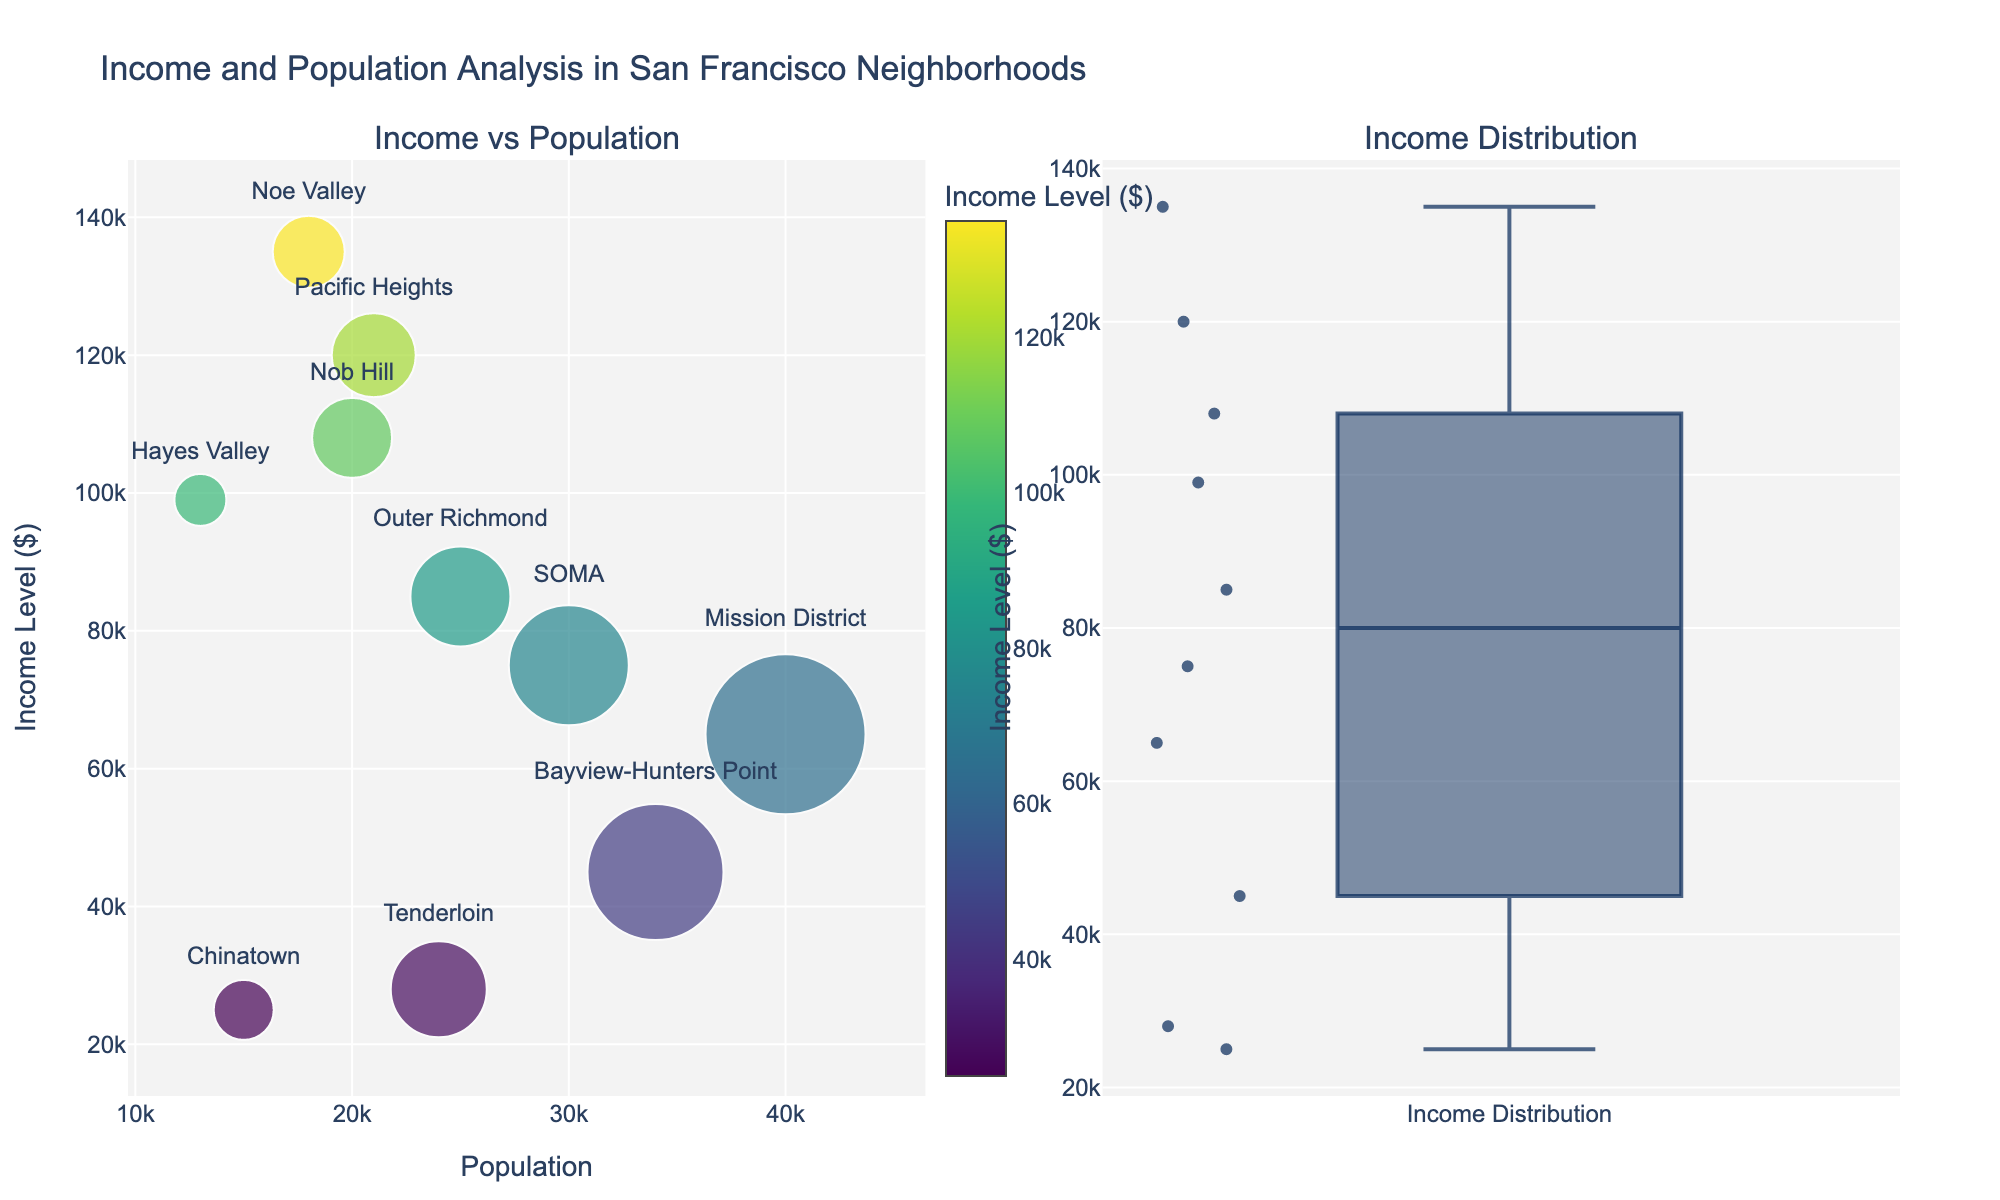What's the title of the figure? The title of the figure is displayed at the top and provides a summary of what the figure is about. In this case, the title is displayed as 'Income and Population Analysis in San Francisco Neighborhoods'.
Answer: Income and Population Analysis in San Francisco Neighborhoods How does the color of markers indicate income levels? The color of the markers in the scatter plot corresponds to income levels, with a colorscale (Viridis) shown on the right side. Brighter colors represent higher income levels, while darker colors represent lower income levels.
Answer: Colors represent income levels Which neighborhood has the smallest population? Look at the scatter plot and observe the x-axis values (Population). The smallest population marker is the furthest to the left. The text label on this marker indicates "Hayes Valley" with a population of 13,000.
Answer: Hayes Valley What's the median income level across the neighborhoods? In the box plot, the median is represented by the central line within the box. From the visual, the median income level is close to 75,000 dollars.
Answer: Around $75,000 Which neighborhoods have income levels above $100,000? In the scatter plot, find markers with y-axis values (Income Level) above $100,000 and read their corresponding text labels. These neighborhoods are Nob Hill, Pacific Heights, and Noe Valley.
Answer: Nob Hill, Pacific Heights, Noe Valley How do Pacific Heights and Bayview-Hunters Point compare in terms of income levels? Examine the scatter plot for the points labeled "Pacific Heights" and "Bayview-Hunters Point". Pacific Heights has an income level of 120,000 dollars, and Bayview-Hunters Point has an income level of 45,000 dollars. Therefore, Pacific Heights has a higher income level than Bayview-Hunters Point.
Answer: Pacific Heights has higher income What is the range of income levels shown in the box plot? The box plot shows the range from the lowest to the highest income level. The "whiskers" (lines) extend from the minimum to the maximum value. The range is from 25,000 dollars to 135,000 dollars.
Answer: $25,000 to $135,000 What's the relationship between population size and the size of markers in the scatter plot? In the scatter plot, the size of each marker is proportional to the population size of the respective neighborhood. Larger markers indicate larger populations.
Answer: Larger markers mean larger populations Is there a correlation between population and income level among the neighborhoods? By observing the scatter plot, notice how the markers are positioned relative to the x-axis (Population) and y-axis (Income Level). There is no clear pattern indicating a positive or negative correlation. The data points are scattered without a clear trend line.
Answer: No clear correlation Which neighborhood appears in the scatter plot with the highest income level and what is that level? Identify the marker at the highest point on the y-axis in the scatter plot. The text label on this marker indicates "Noe Valley", with an income level of 135,000 dollars.
Answer: Noe Valley, $135,000 